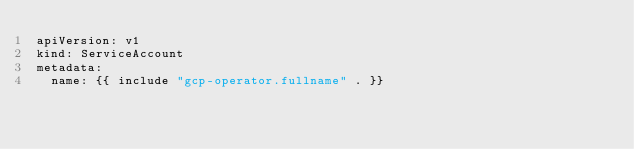Convert code to text. <code><loc_0><loc_0><loc_500><loc_500><_YAML_>apiVersion: v1
kind: ServiceAccount
metadata:
  name: {{ include "gcp-operator.fullname" . }}
</code> 